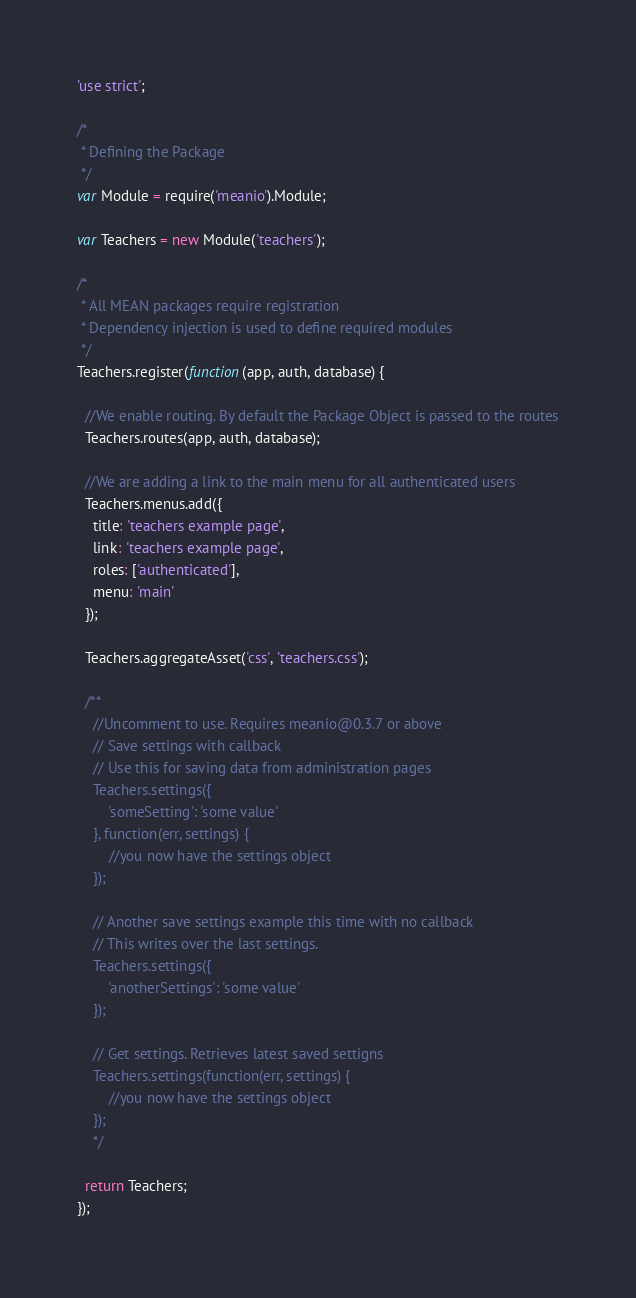<code> <loc_0><loc_0><loc_500><loc_500><_JavaScript_>'use strict';

/*
 * Defining the Package
 */
var Module = require('meanio').Module;

var Teachers = new Module('teachers');

/*
 * All MEAN packages require registration
 * Dependency injection is used to define required modules
 */
Teachers.register(function(app, auth, database) {

  //We enable routing. By default the Package Object is passed to the routes
  Teachers.routes(app, auth, database);

  //We are adding a link to the main menu for all authenticated users
  Teachers.menus.add({
    title: 'teachers example page',
    link: 'teachers example page',
    roles: ['authenticated'],
    menu: 'main'
  });
  
  Teachers.aggregateAsset('css', 'teachers.css');

  /**
    //Uncomment to use. Requires meanio@0.3.7 or above
    // Save settings with callback
    // Use this for saving data from administration pages
    Teachers.settings({
        'someSetting': 'some value'
    }, function(err, settings) {
        //you now have the settings object
    });

    // Another save settings example this time with no callback
    // This writes over the last settings.
    Teachers.settings({
        'anotherSettings': 'some value'
    });

    // Get settings. Retrieves latest saved settigns
    Teachers.settings(function(err, settings) {
        //you now have the settings object
    });
    */

  return Teachers;
});
</code> 